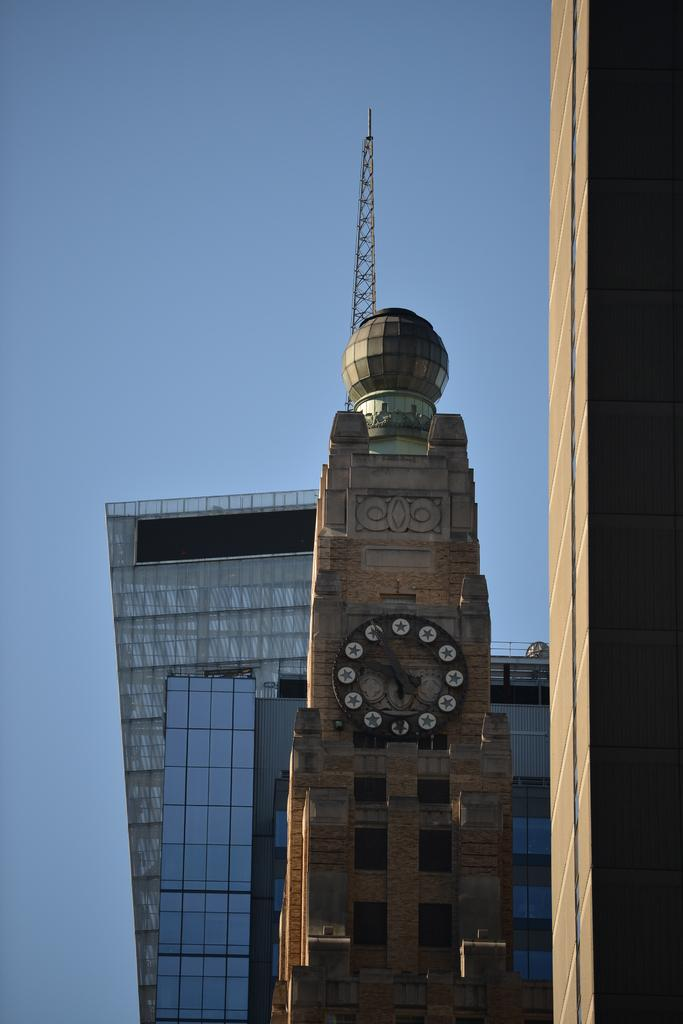What type of structures can be seen in the image? There are buildings and a tower in the image. What can be seen in the background of the image? The sky is visible in the background of the image. How many laborers are working on the floor in the image? There are no laborers or floors mentioned in the image; it only features buildings, a tower, and the sky. 